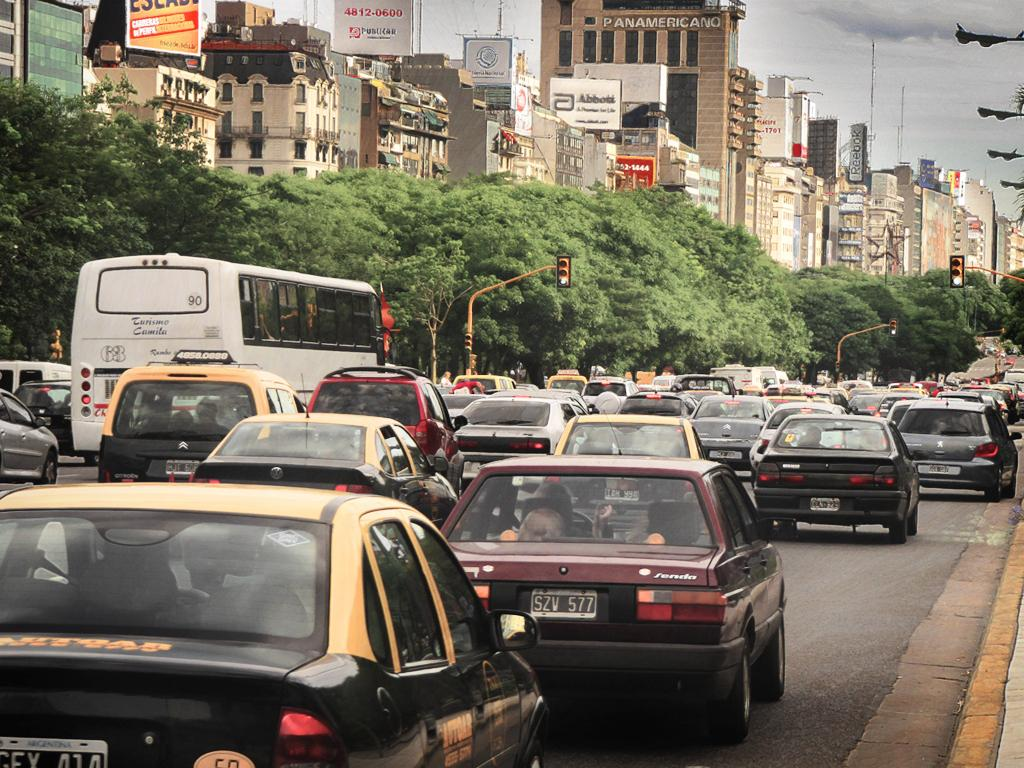Provide a one-sentence caption for the provided image. The Panamericano Building stands tall over a busy thoroughfare. 